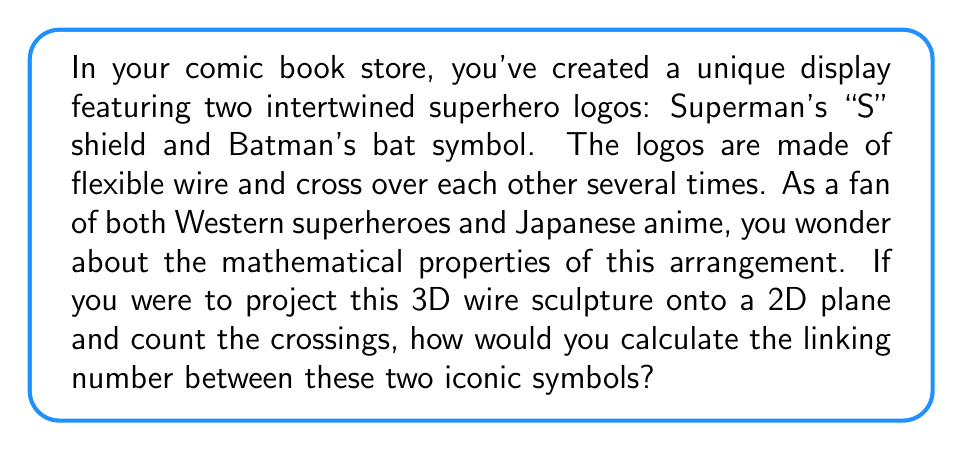Teach me how to tackle this problem. To calculate the linking number between two curves (in this case, the Superman and Batman logos), we can use the following steps:

1. Project the 3D curves onto a 2D plane.

2. Assign a direction to each curve (e.g., clockwise for Superman's logo and counterclockwise for Batman's logo).

3. At each crossing point, determine if it's a positive or negative crossing:
   - Positive crossing: The over-strand points to the right of the under-strand's direction.
   - Negative crossing: The over-strand points to the left of the under-strand's direction.

4. Count the number of positive and negative crossings.

5. Calculate the linking number using the formula:

   $$ Lk = \frac{1}{2}(n_+ - n_-) $$

   Where $Lk$ is the linking number, $n_+$ is the number of positive crossings, and $n_-$ is the number of negative crossings.

For example, let's assume the projected logos have 6 crossing points:
- 4 positive crossings $(n_+ = 4)$
- 2 negative crossings $(n_- = 2)$

Applying the formula:

$$ Lk = \frac{1}{2}(4 - 2) = \frac{1}{2}(2) = 1 $$

The linking number in this case would be 1, indicating that the logos are linked once.

Note that the linking number is an integer and is invariant under continuous deformations of the curves, as long as they don't pass through each other.
Answer: $$ Lk = \frac{1}{2}(n_+ - n_-) $$ 